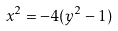Convert formula to latex. <formula><loc_0><loc_0><loc_500><loc_500>x ^ { 2 } = - 4 ( y ^ { 2 } - 1 )</formula> 